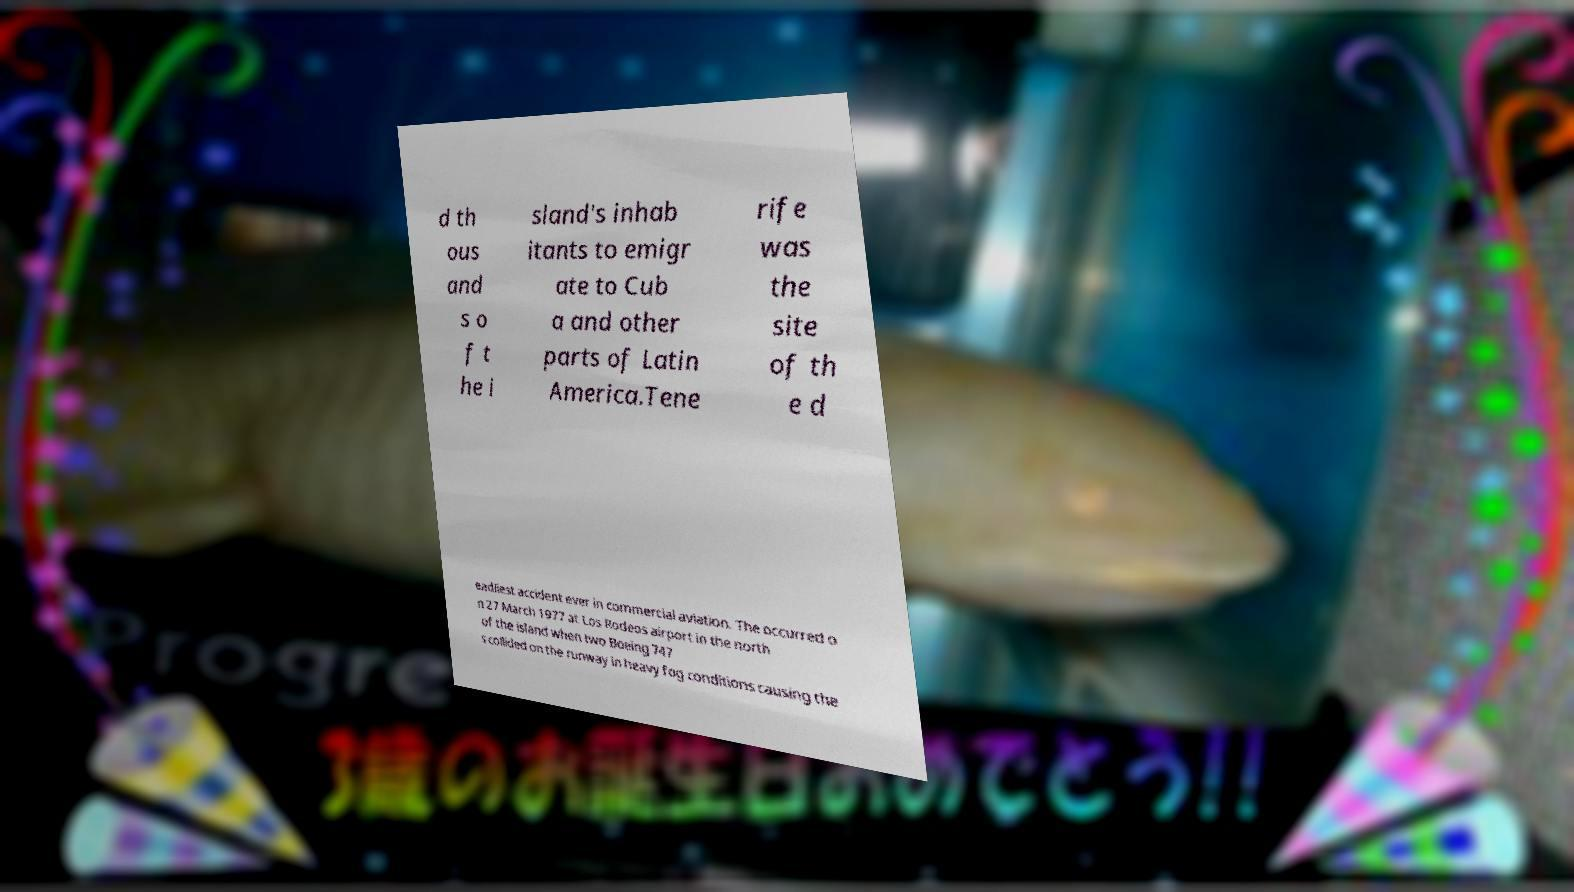Can you read and provide the text displayed in the image?This photo seems to have some interesting text. Can you extract and type it out for me? d th ous and s o f t he i sland's inhab itants to emigr ate to Cub a and other parts of Latin America.Tene rife was the site of th e d eadliest accident ever in commercial aviation. The occurred o n 27 March 1977 at Los Rodeos airport in the north of the island when two Boeing 747 s collided on the runway in heavy fog conditions causing the 